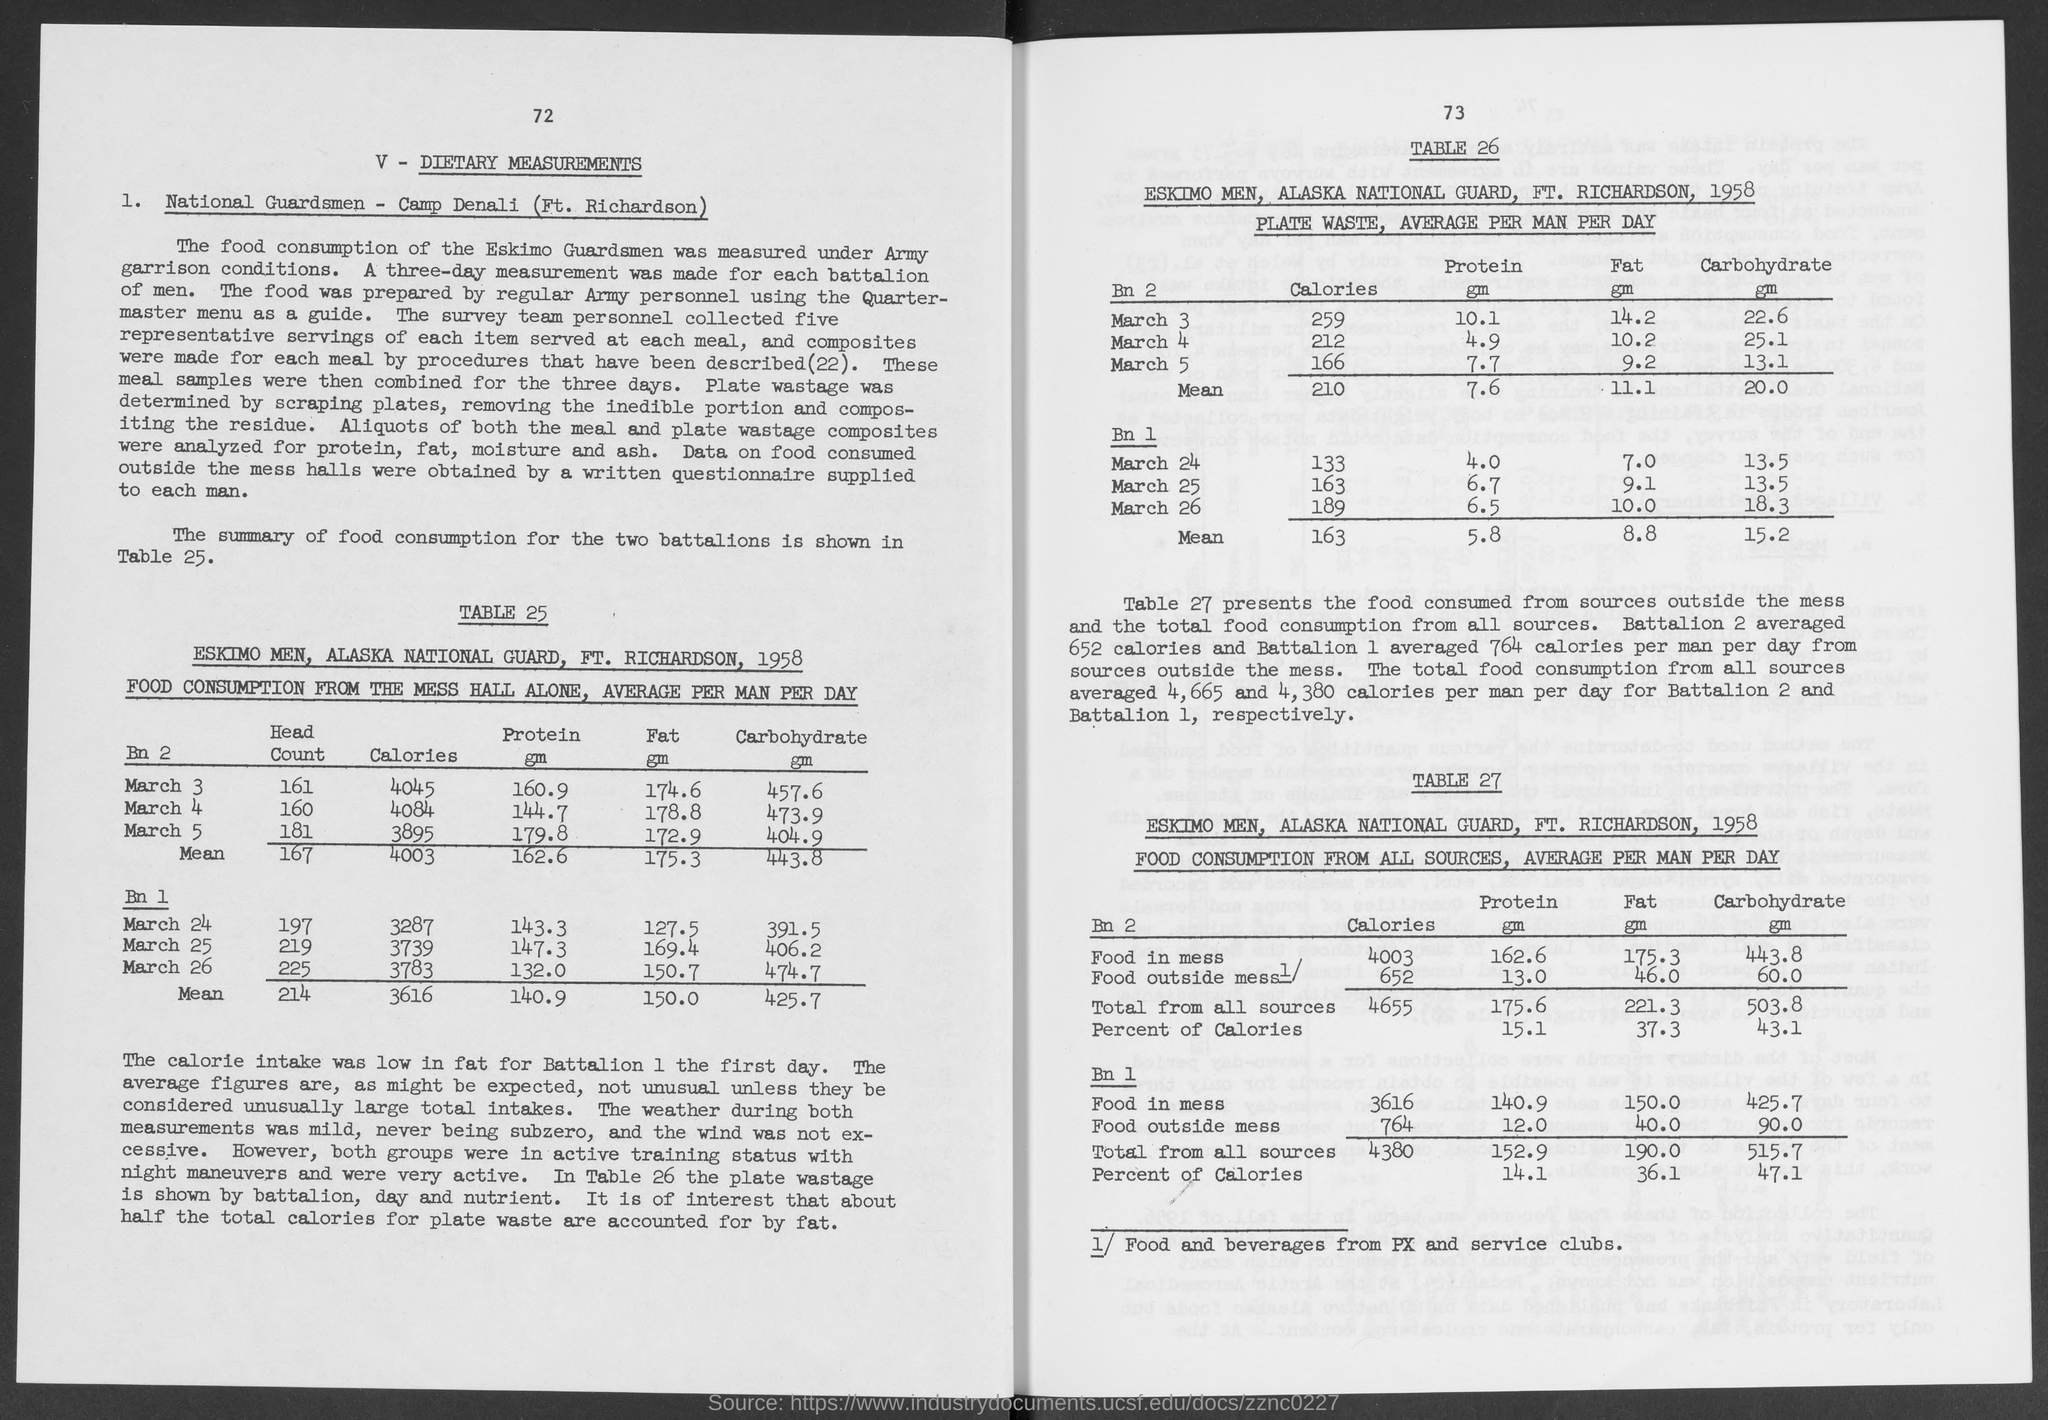What is the number above dietary measurements ?
Your answer should be compact. 72. 